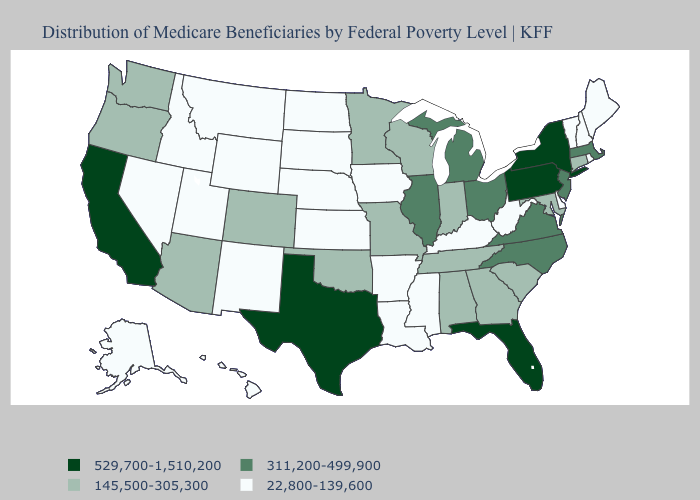Which states have the lowest value in the USA?
Keep it brief. Alaska, Arkansas, Delaware, Hawaii, Idaho, Iowa, Kansas, Kentucky, Louisiana, Maine, Mississippi, Montana, Nebraska, Nevada, New Hampshire, New Mexico, North Dakota, Rhode Island, South Dakota, Utah, Vermont, West Virginia, Wyoming. Name the states that have a value in the range 529,700-1,510,200?
Write a very short answer. California, Florida, New York, Pennsylvania, Texas. What is the value of Missouri?
Concise answer only. 145,500-305,300. Among the states that border New Mexico , which have the highest value?
Quick response, please. Texas. Does Alaska have the lowest value in the USA?
Be succinct. Yes. Does Arizona have the lowest value in the USA?
Keep it brief. No. What is the value of South Dakota?
Give a very brief answer. 22,800-139,600. Name the states that have a value in the range 145,500-305,300?
Keep it brief. Alabama, Arizona, Colorado, Connecticut, Georgia, Indiana, Maryland, Minnesota, Missouri, Oklahoma, Oregon, South Carolina, Tennessee, Washington, Wisconsin. What is the highest value in states that border Oklahoma?
Answer briefly. 529,700-1,510,200. Among the states that border North Dakota , which have the lowest value?
Be succinct. Montana, South Dakota. Does the first symbol in the legend represent the smallest category?
Concise answer only. No. What is the lowest value in states that border Texas?
Keep it brief. 22,800-139,600. What is the value of Hawaii?
Write a very short answer. 22,800-139,600. Name the states that have a value in the range 145,500-305,300?
Quick response, please. Alabama, Arizona, Colorado, Connecticut, Georgia, Indiana, Maryland, Minnesota, Missouri, Oklahoma, Oregon, South Carolina, Tennessee, Washington, Wisconsin. How many symbols are there in the legend?
Be succinct. 4. 